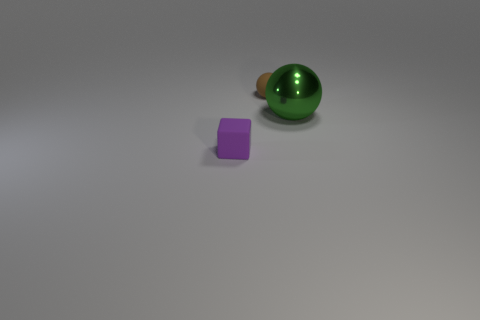There is a large green thing; what shape is it?
Give a very brief answer. Sphere. What number of tiny balls are to the left of the thing that is to the left of the small matte thing behind the purple block?
Ensure brevity in your answer.  0. What number of other objects are the same material as the green object?
Your answer should be very brief. 0. What is the material of the object that is the same size as the block?
Give a very brief answer. Rubber. Do the ball that is to the left of the shiny ball and the large shiny object behind the tiny purple rubber thing have the same color?
Keep it short and to the point. No. Are there any other shiny objects that have the same shape as the big green metallic object?
Your answer should be compact. No. There is a purple matte object that is the same size as the brown matte ball; what shape is it?
Your answer should be compact. Cube. What size is the rubber object that is to the left of the brown ball?
Offer a terse response. Small. How many spheres are the same size as the green object?
Offer a terse response. 0. There is a tiny thing that is made of the same material as the purple block; what color is it?
Offer a terse response. Brown. 